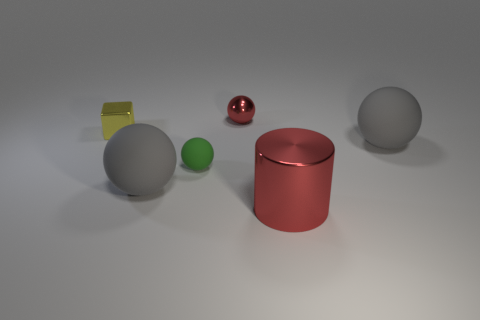What is the shape of the small red object that is the same material as the big red cylinder?
Provide a short and direct response. Sphere. Is the shape of the green object the same as the small red thing?
Your answer should be very brief. Yes. What color is the big cylinder?
Offer a terse response. Red. What number of things are big metal cylinders or small blocks?
Provide a short and direct response. 2. Is the number of large red metallic objects that are behind the small yellow metal thing less than the number of red metallic cylinders?
Your answer should be compact. Yes. Is the number of large matte balls to the right of the cylinder greater than the number of gray matte things that are to the left of the block?
Your response must be concise. Yes. Are there any other things of the same color as the cube?
Offer a very short reply. No. What is the material of the small yellow cube that is left of the green ball?
Keep it short and to the point. Metal. Does the shiny cylinder have the same size as the red ball?
Offer a terse response. No. What number of other things are the same size as the red cylinder?
Offer a very short reply. 2. 